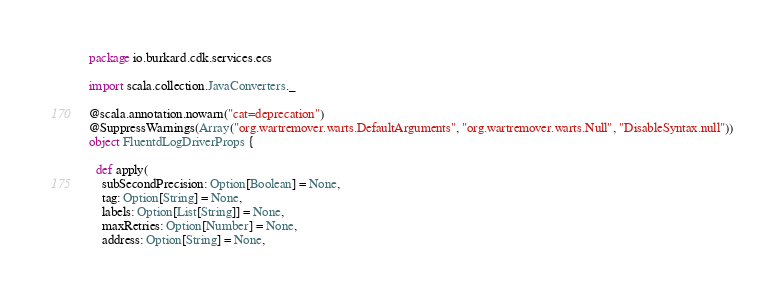Convert code to text. <code><loc_0><loc_0><loc_500><loc_500><_Scala_>package io.burkard.cdk.services.ecs

import scala.collection.JavaConverters._

@scala.annotation.nowarn("cat=deprecation")
@SuppressWarnings(Array("org.wartremover.warts.DefaultArguments", "org.wartremover.warts.Null", "DisableSyntax.null"))
object FluentdLogDriverProps {

  def apply(
    subSecondPrecision: Option[Boolean] = None,
    tag: Option[String] = None,
    labels: Option[List[String]] = None,
    maxRetries: Option[Number] = None,
    address: Option[String] = None,</code> 